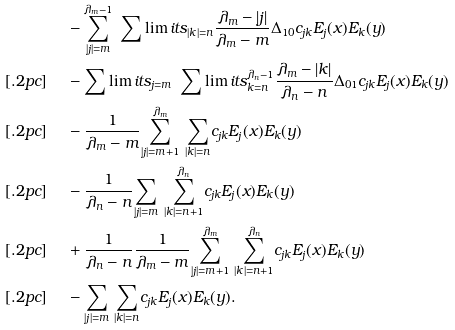<formula> <loc_0><loc_0><loc_500><loc_500>& \quad \ - \underset { | j | = m } { \overset { \lambda _ { m } - 1 } { \sum } } \ \sum \lim i t s _ { | k | = n } \frac { \lambda _ { m } - | j | } { \lambda _ { m } - m } \Delta _ { 1 0 } c _ { j k } E _ { j } ( x ) E _ { k } ( y ) \\ [ . 2 p c ] & \quad \ - \sum \lim i t s _ { j = m } \ \sum \lim i t s _ { k = n } ^ { \lambda _ { n } - 1 } \frac { \lambda _ { m } - | k | } { \lambda _ { n } - n } \Delta _ { 0 1 } c _ { j k } E _ { j } ( x ) E _ { k } ( y ) \\ [ . 2 p c ] & \quad \ - \frac { 1 } { \lambda _ { m } - m } \underset { | j | = m + 1 } { \overset { \lambda _ { m } } { \sum } } \ \underset { | k | = n } { { \sum } } c _ { j k } E _ { j } ( x ) E _ { k } ( y ) \\ [ . 2 p c ] & \quad \ - \frac { 1 } { \lambda _ { n } - n } \underset { | j | = m } { { \sum } } \ \underset { | k | = n + 1 } { \overset { \lambda _ { n } } { \sum } } c _ { j k } E _ { j } ( x ) E _ { k } ( y ) \\ [ . 2 p c ] & \quad \ + \frac { 1 } { \lambda _ { n } - n } \frac { 1 } { \lambda _ { m } - m } \underset { | j | = m + 1 } { \overset { \lambda _ { m } } { \sum } } \ \underset { | k | = n + 1 } { \overset { \lambda _ { n } } { \sum } } c _ { j k } E _ { j } ( x ) E _ { k } ( y ) \\ [ . 2 p c ] & \quad \ - \underset { | j | = m } { { \sum } } \ \underset { | k | = n } { { \sum } } c _ { j k } E _ { j } ( x ) E _ { k } ( y ) .</formula> 